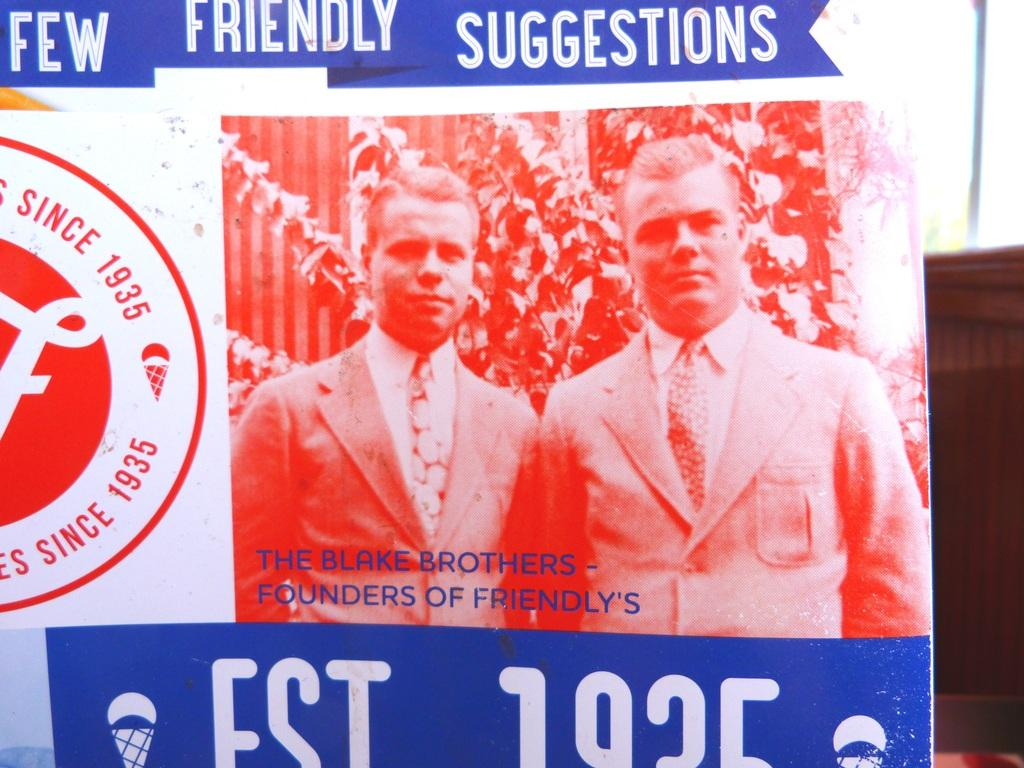What is featured on the poster in the image? There is a poster with text in the image. What else can be seen in the image besides the poster? There is a photo in the image. How many people are in the photo? The photo contains two persons. What shape is the playground in the image? There is no playground present in the image; it features a poster with text and a photo containing two persons. 